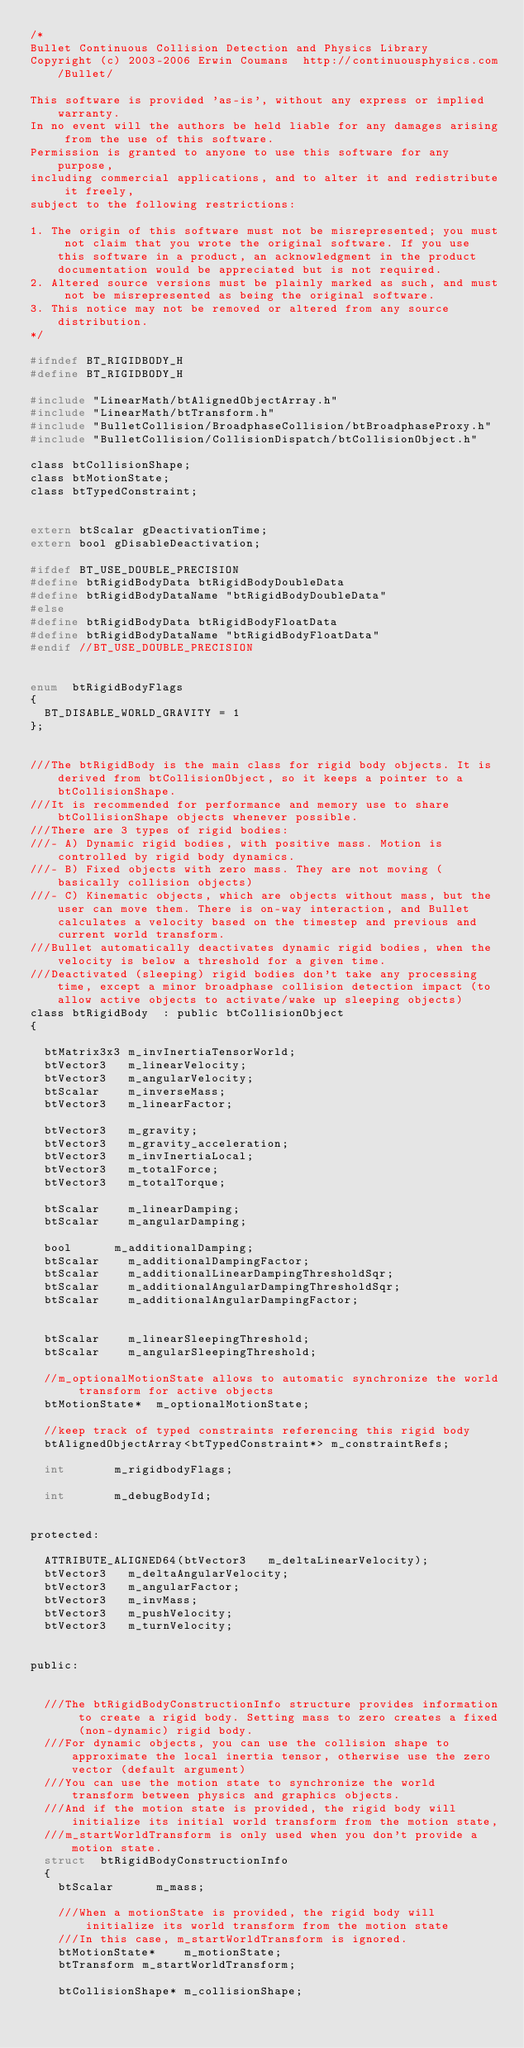Convert code to text. <code><loc_0><loc_0><loc_500><loc_500><_C_>/*
Bullet Continuous Collision Detection and Physics Library
Copyright (c) 2003-2006 Erwin Coumans  http://continuousphysics.com/Bullet/

This software is provided 'as-is', without any express or implied warranty.
In no event will the authors be held liable for any damages arising from the use of this software.
Permission is granted to anyone to use this software for any purpose, 
including commercial applications, and to alter it and redistribute it freely, 
subject to the following restrictions:

1. The origin of this software must not be misrepresented; you must not claim that you wrote the original software. If you use this software in a product, an acknowledgment in the product documentation would be appreciated but is not required.
2. Altered source versions must be plainly marked as such, and must not be misrepresented as being the original software.
3. This notice may not be removed or altered from any source distribution.
*/

#ifndef BT_RIGIDBODY_H
#define BT_RIGIDBODY_H

#include "LinearMath/btAlignedObjectArray.h"
#include "LinearMath/btTransform.h"
#include "BulletCollision/BroadphaseCollision/btBroadphaseProxy.h"
#include "BulletCollision/CollisionDispatch/btCollisionObject.h"

class btCollisionShape;
class btMotionState;
class btTypedConstraint;


extern btScalar gDeactivationTime;
extern bool gDisableDeactivation;

#ifdef BT_USE_DOUBLE_PRECISION
#define btRigidBodyData	btRigidBodyDoubleData
#define btRigidBodyDataName	"btRigidBodyDoubleData"
#else
#define btRigidBodyData	btRigidBodyFloatData
#define btRigidBodyDataName	"btRigidBodyFloatData"
#endif //BT_USE_DOUBLE_PRECISION


enum	btRigidBodyFlags
{
	BT_DISABLE_WORLD_GRAVITY = 1
};


///The btRigidBody is the main class for rigid body objects. It is derived from btCollisionObject, so it keeps a pointer to a btCollisionShape.
///It is recommended for performance and memory use to share btCollisionShape objects whenever possible.
///There are 3 types of rigid bodies: 
///- A) Dynamic rigid bodies, with positive mass. Motion is controlled by rigid body dynamics.
///- B) Fixed objects with zero mass. They are not moving (basically collision objects)
///- C) Kinematic objects, which are objects without mass, but the user can move them. There is on-way interaction, and Bullet calculates a velocity based on the timestep and previous and current world transform.
///Bullet automatically deactivates dynamic rigid bodies, when the velocity is below a threshold for a given time.
///Deactivated (sleeping) rigid bodies don't take any processing time, except a minor broadphase collision detection impact (to allow active objects to activate/wake up sleeping objects)
class btRigidBody  : public btCollisionObject
{

	btMatrix3x3	m_invInertiaTensorWorld;
	btVector3		m_linearVelocity;
	btVector3		m_angularVelocity;
	btScalar		m_inverseMass;
	btVector3		m_linearFactor;

	btVector3		m_gravity;	
	btVector3		m_gravity_acceleration;
	btVector3		m_invInertiaLocal;
	btVector3		m_totalForce;
	btVector3		m_totalTorque;
	
	btScalar		m_linearDamping;
	btScalar		m_angularDamping;

	bool			m_additionalDamping;
	btScalar		m_additionalDampingFactor;
	btScalar		m_additionalLinearDampingThresholdSqr;
	btScalar		m_additionalAngularDampingThresholdSqr;
	btScalar		m_additionalAngularDampingFactor;


	btScalar		m_linearSleepingThreshold;
	btScalar		m_angularSleepingThreshold;

	//m_optionalMotionState allows to automatic synchronize the world transform for active objects
	btMotionState*	m_optionalMotionState;

	//keep track of typed constraints referencing this rigid body
	btAlignedObjectArray<btTypedConstraint*> m_constraintRefs;

	int				m_rigidbodyFlags;
	
	int				m_debugBodyId;
	

protected:

	ATTRIBUTE_ALIGNED64(btVector3		m_deltaLinearVelocity);
	btVector3		m_deltaAngularVelocity;
	btVector3		m_angularFactor;
	btVector3		m_invMass;
	btVector3		m_pushVelocity;
	btVector3		m_turnVelocity;


public:


	///The btRigidBodyConstructionInfo structure provides information to create a rigid body. Setting mass to zero creates a fixed (non-dynamic) rigid body.
	///For dynamic objects, you can use the collision shape to approximate the local inertia tensor, otherwise use the zero vector (default argument)
	///You can use the motion state to synchronize the world transform between physics and graphics objects. 
	///And if the motion state is provided, the rigid body will initialize its initial world transform from the motion state,
	///m_startWorldTransform is only used when you don't provide a motion state.
	struct	btRigidBodyConstructionInfo
	{
		btScalar			m_mass;

		///When a motionState is provided, the rigid body will initialize its world transform from the motion state
		///In this case, m_startWorldTransform is ignored.
		btMotionState*		m_motionState;
		btTransform	m_startWorldTransform;

		btCollisionShape*	m_collisionShape;</code> 